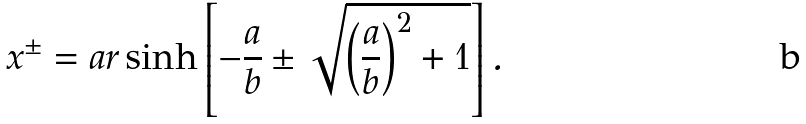Convert formula to latex. <formula><loc_0><loc_0><loc_500><loc_500>x ^ { \pm } = a r \sinh \left [ - \frac { a } { b } \pm \sqrt { \left ( \frac { a } { b } \right ) ^ { 2 } + 1 } \right ] .</formula> 